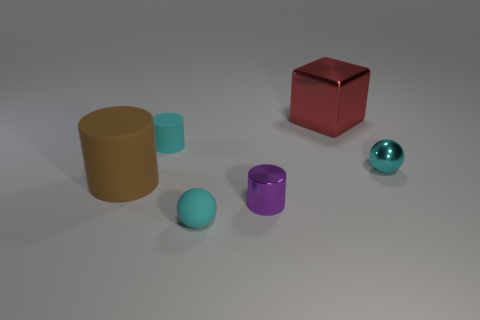Subtract all matte cylinders. How many cylinders are left? 1 Add 3 tiny rubber spheres. How many objects exist? 9 Subtract all cubes. How many objects are left? 5 Subtract 0 green cubes. How many objects are left? 6 Subtract all brown balls. Subtract all red blocks. How many balls are left? 2 Subtract all cyan objects. Subtract all big red shiny objects. How many objects are left? 2 Add 6 brown rubber objects. How many brown rubber objects are left? 7 Add 6 red metallic things. How many red metallic things exist? 7 